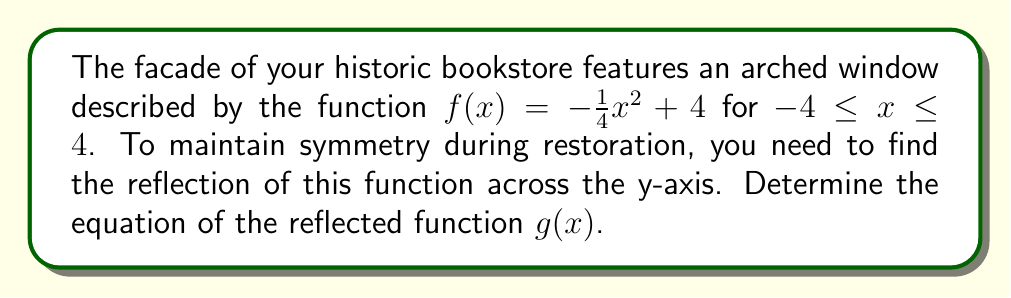Teach me how to tackle this problem. To find the reflection of a function across the y-axis, we replace every $x$ in the original function with $-x$. This process effectively "flips" the function horizontally.

Given: $f(x) = -\frac{1}{4}x^2 + 4$

Steps to find $g(x)$:

1) Replace every $x$ with $-x$ in the original function:
   $g(x) = -\frac{1}{4}(-x)^2 + 4$

2) Simplify the expression:
   $g(x) = -\frac{1}{4}(x^2) + 4$
   
3) The negative signs cancel out:
   $g(x) = -\frac{1}{4}x^2 + 4$

Note that in this case, $g(x) = f(x)$. This means the function is symmetric about the y-axis, which is ideal for maintaining the architectural symmetry of your bookstore's facade.

[asy]
import graph;
size(200);
real f(real x) {return -1/4*x^2 + 4;}
draw(graph(f,-4,4),blue);
draw((-4,0)--(4,0),arrow=Arrow(TeXHead));
draw((0,-1)--(0,5),arrow=Arrow(TeXHead));
label("x",(4,0),E);
label("y",(0,5),N);
label("$f(x) = g(x) = -\frac{1}{4}x^2 + 4$",(0,-0.5),S);
[/asy]
Answer: $g(x) = -\frac{1}{4}x^2 + 4$ 